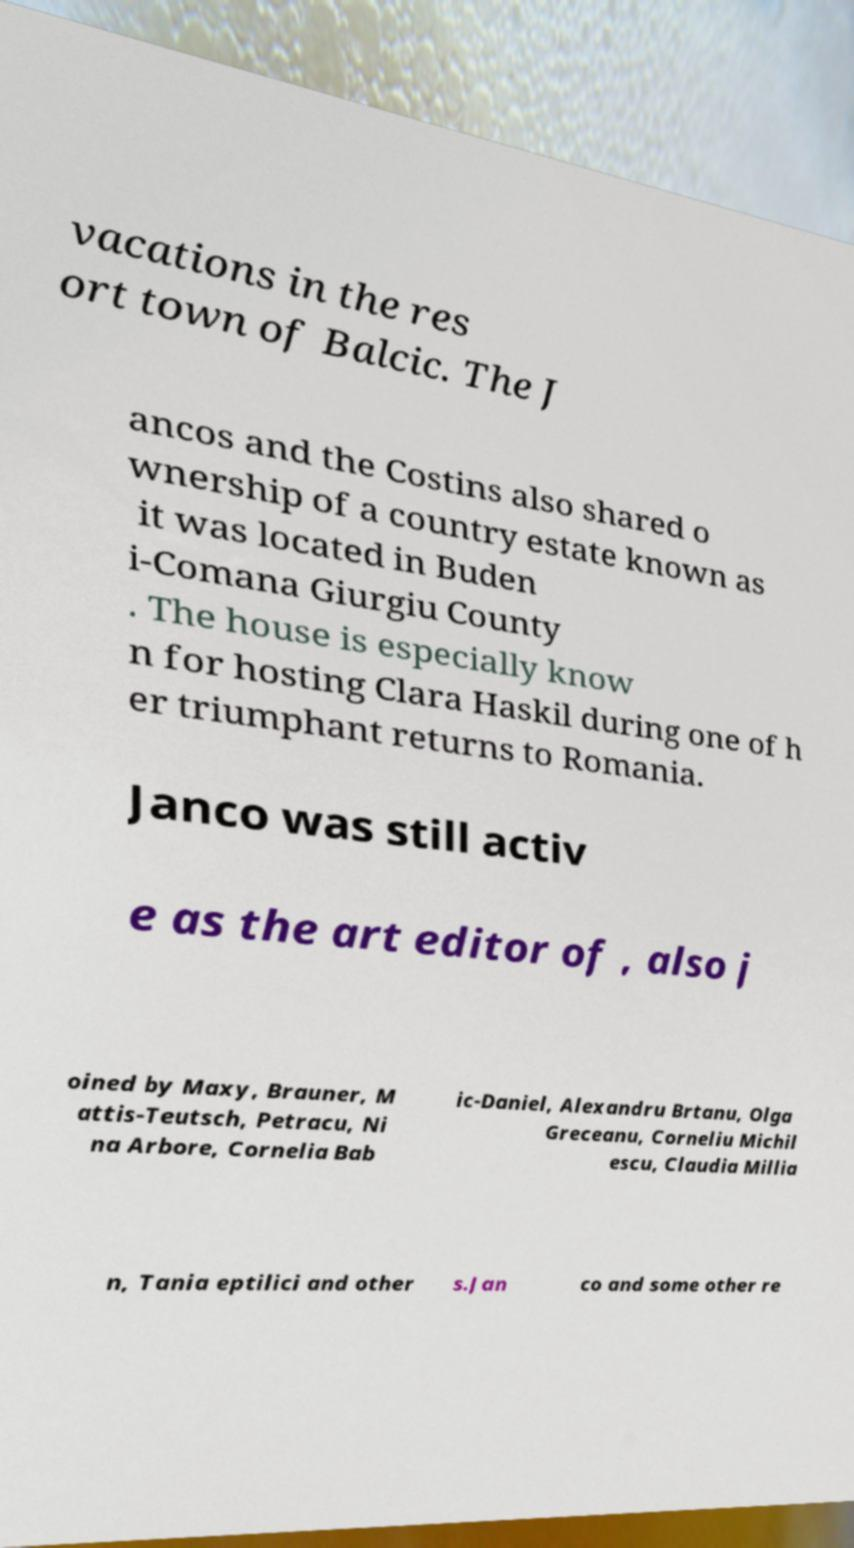Can you accurately transcribe the text from the provided image for me? vacations in the res ort town of Balcic. The J ancos and the Costins also shared o wnership of a country estate known as it was located in Buden i-Comana Giurgiu County . The house is especially know n for hosting Clara Haskil during one of h er triumphant returns to Romania. Janco was still activ e as the art editor of , also j oined by Maxy, Brauner, M attis-Teutsch, Petracu, Ni na Arbore, Cornelia Bab ic-Daniel, Alexandru Brtanu, Olga Greceanu, Corneliu Michil escu, Claudia Millia n, Tania eptilici and other s.Jan co and some other re 